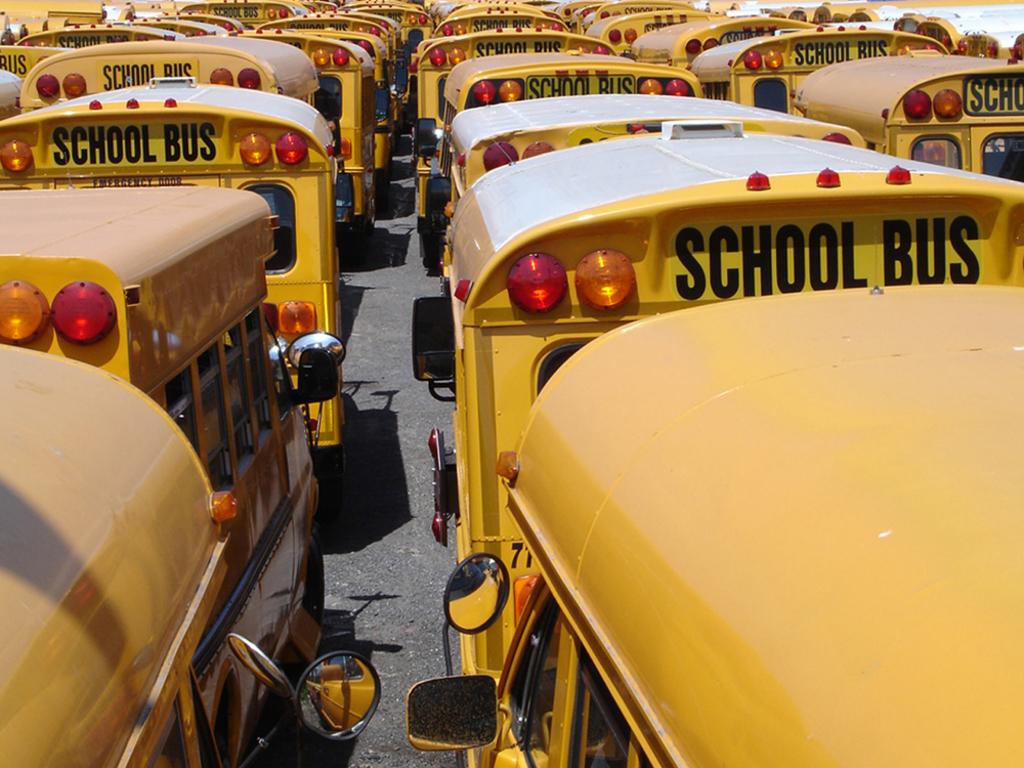What type of objects are present in the image? There are vehicles in the image. What color are the vehicles? The vehicles are yellow in color. What features can be seen on the vehicles? Mirrors, windows, and lights are visible on the vehicles. Are there any fairies flying around the vehicles in the image? No, there are no fairies present in the image. What type of underwear are the vehicles wearing in the image? Vehicles do not wear underwear, as they are inanimate objects. 